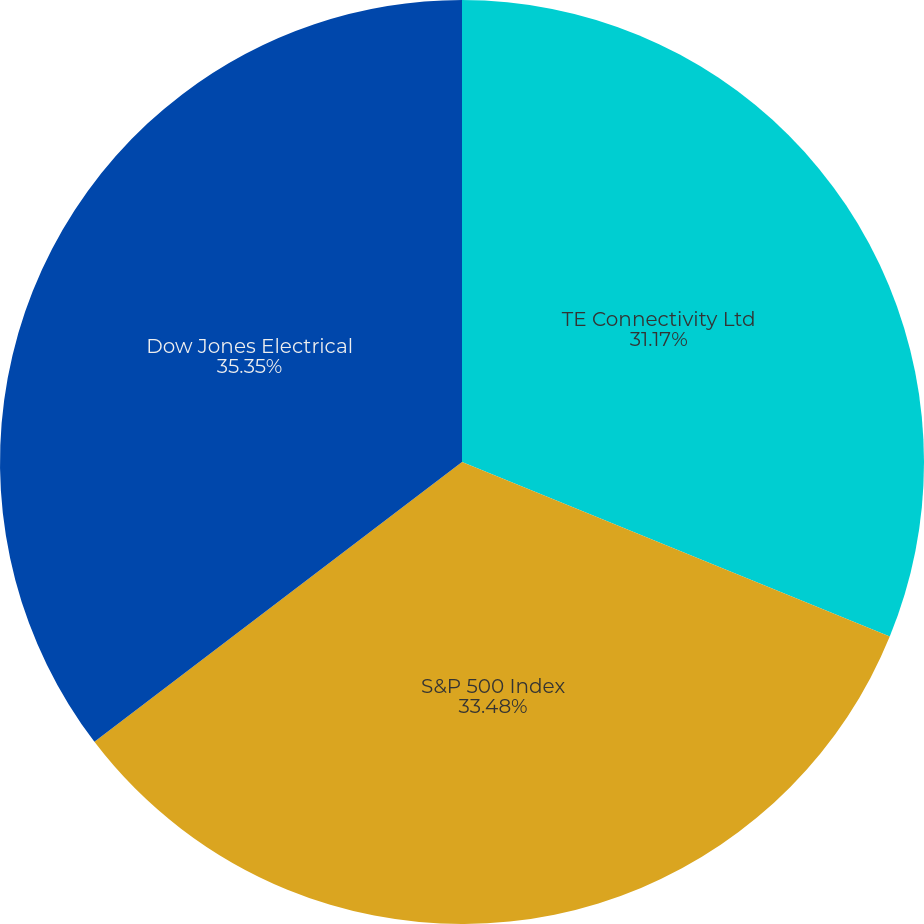Convert chart to OTSL. <chart><loc_0><loc_0><loc_500><loc_500><pie_chart><fcel>TE Connectivity Ltd<fcel>S&P 500 Index<fcel>Dow Jones Electrical<nl><fcel>31.17%<fcel>33.48%<fcel>35.36%<nl></chart> 